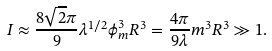Convert formula to latex. <formula><loc_0><loc_0><loc_500><loc_500>I \approx \frac { 8 \sqrt { 2 } \pi } { 9 } \lambda ^ { 1 / 2 } \phi _ { m } ^ { 3 } R ^ { 3 } = \frac { 4 \pi } { 9 \lambda } m ^ { 3 } R ^ { 3 } \gg 1 .</formula> 